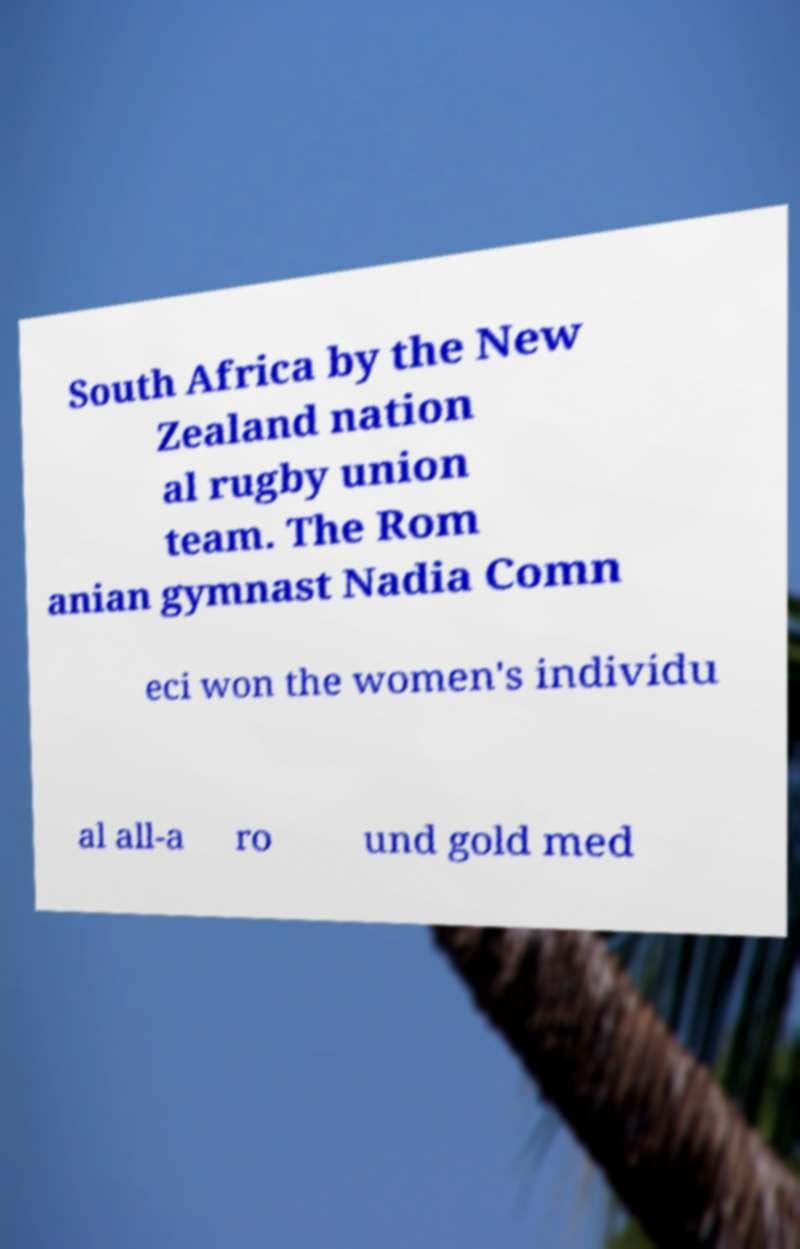What messages or text are displayed in this image? I need them in a readable, typed format. South Africa by the New Zealand nation al rugby union team. The Rom anian gymnast Nadia Comn eci won the women's individu al all-a ro und gold med 